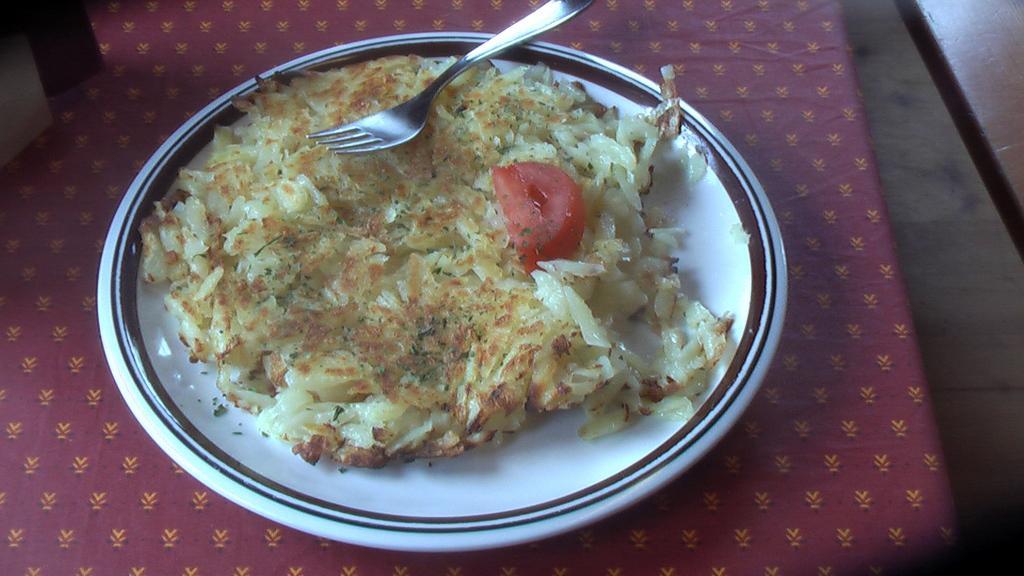How would you summarize this image in a sentence or two? In this image there is a food item on a plate, there is a fork placed on top of the food item, the plate is on top of a table. 